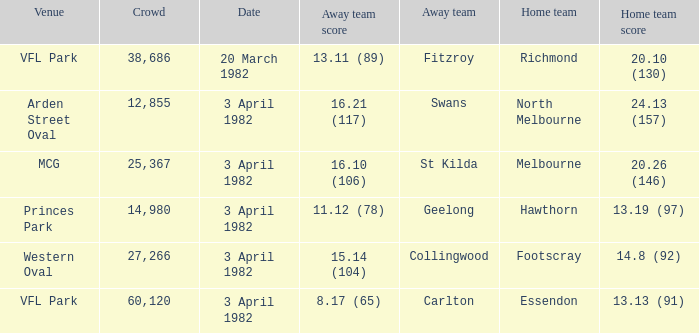When the away team scored 16.21 (117), what was the home teams score? 24.13 (157). 